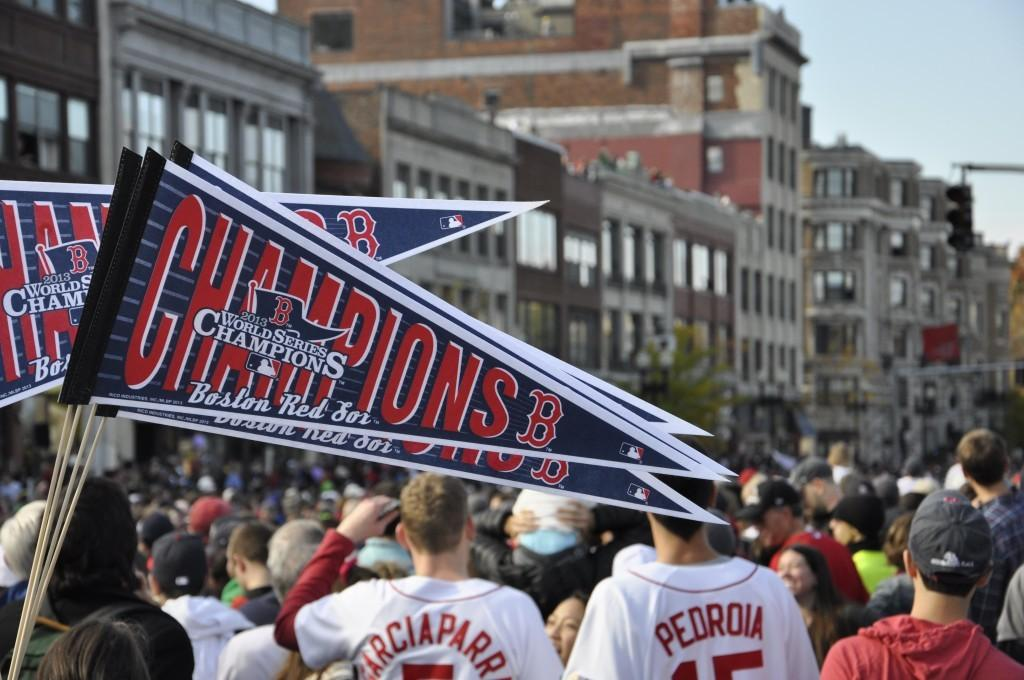<image>
Describe the image concisely. A rally of Boston Red Sock's fans in the street. 